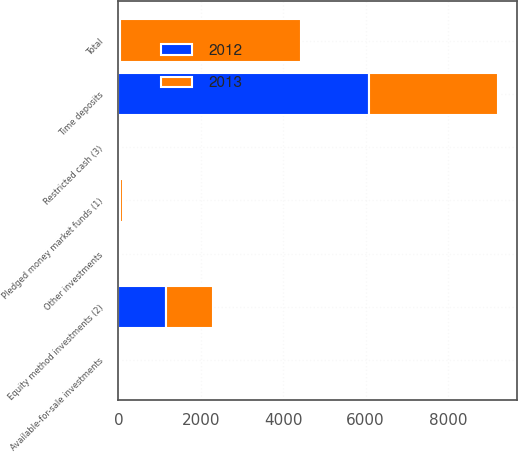Convert chart. <chart><loc_0><loc_0><loc_500><loc_500><stacked_bar_chart><ecel><fcel>Time deposits<fcel>Pledged money market funds (1)<fcel>Available-for-sale investments<fcel>Equity method investments (2)<fcel>Restricted cash (3)<fcel>Other investments<fcel>Total<nl><fcel>2012<fcel>6090<fcel>46<fcel>8<fcel>1164<fcel>33<fcel>33<fcel>46<nl><fcel>2013<fcel>3135<fcel>56<fcel>9<fcel>1137<fcel>25<fcel>35<fcel>4397<nl></chart> 